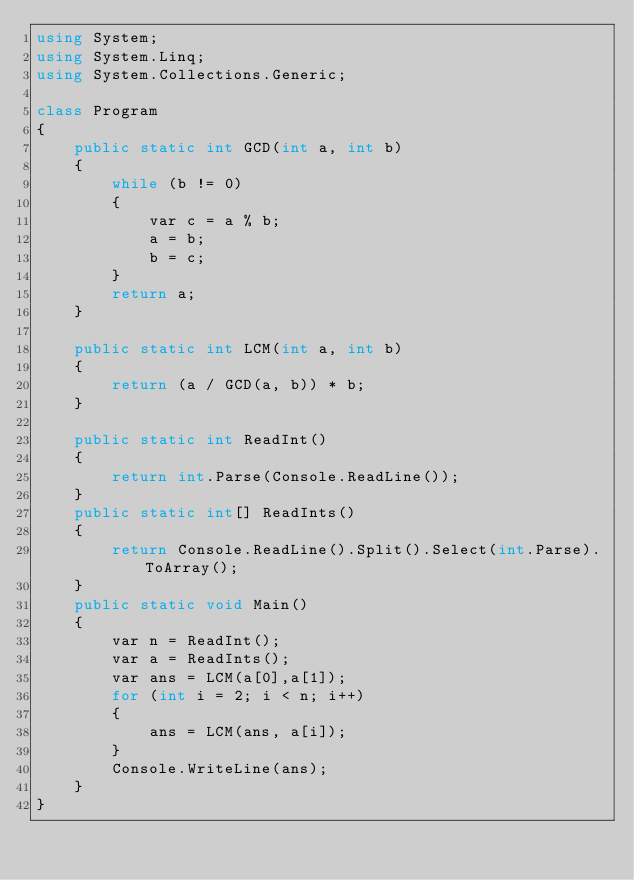Convert code to text. <code><loc_0><loc_0><loc_500><loc_500><_C#_>using System;
using System.Linq;
using System.Collections.Generic;

class Program
{
    public static int GCD(int a, int b)
    {
        while (b != 0)
        {
            var c = a % b;
            a = b;
            b = c;
        }
        return a;
    }

    public static int LCM(int a, int b)
    {
        return (a / GCD(a, b)) * b;
    }

    public static int ReadInt()
    {
        return int.Parse(Console.ReadLine());
    }
    public static int[] ReadInts()
    {
        return Console.ReadLine().Split().Select(int.Parse).ToArray();
    }
    public static void Main()
    {
        var n = ReadInt();
        var a = ReadInts();
        var ans = LCM(a[0],a[1]);
        for (int i = 2; i < n; i++)
        {
            ans = LCM(ans, a[i]);
        }
        Console.WriteLine(ans);
    }
}
</code> 